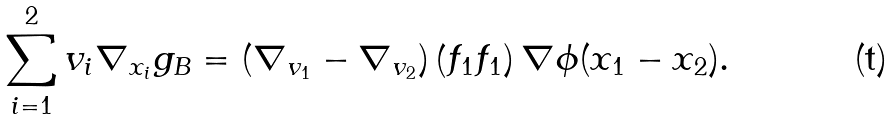Convert formula to latex. <formula><loc_0><loc_0><loc_500><loc_500>\sum _ { i = 1 } ^ { 2 } v _ { i } \nabla _ { x _ { i } } g _ { B } = ( \nabla _ { v _ { 1 } } - \nabla _ { v _ { 2 } } ) \left ( f _ { 1 } f _ { 1 } \right ) \nabla \phi ( x _ { 1 } - x _ { 2 } ) .</formula> 